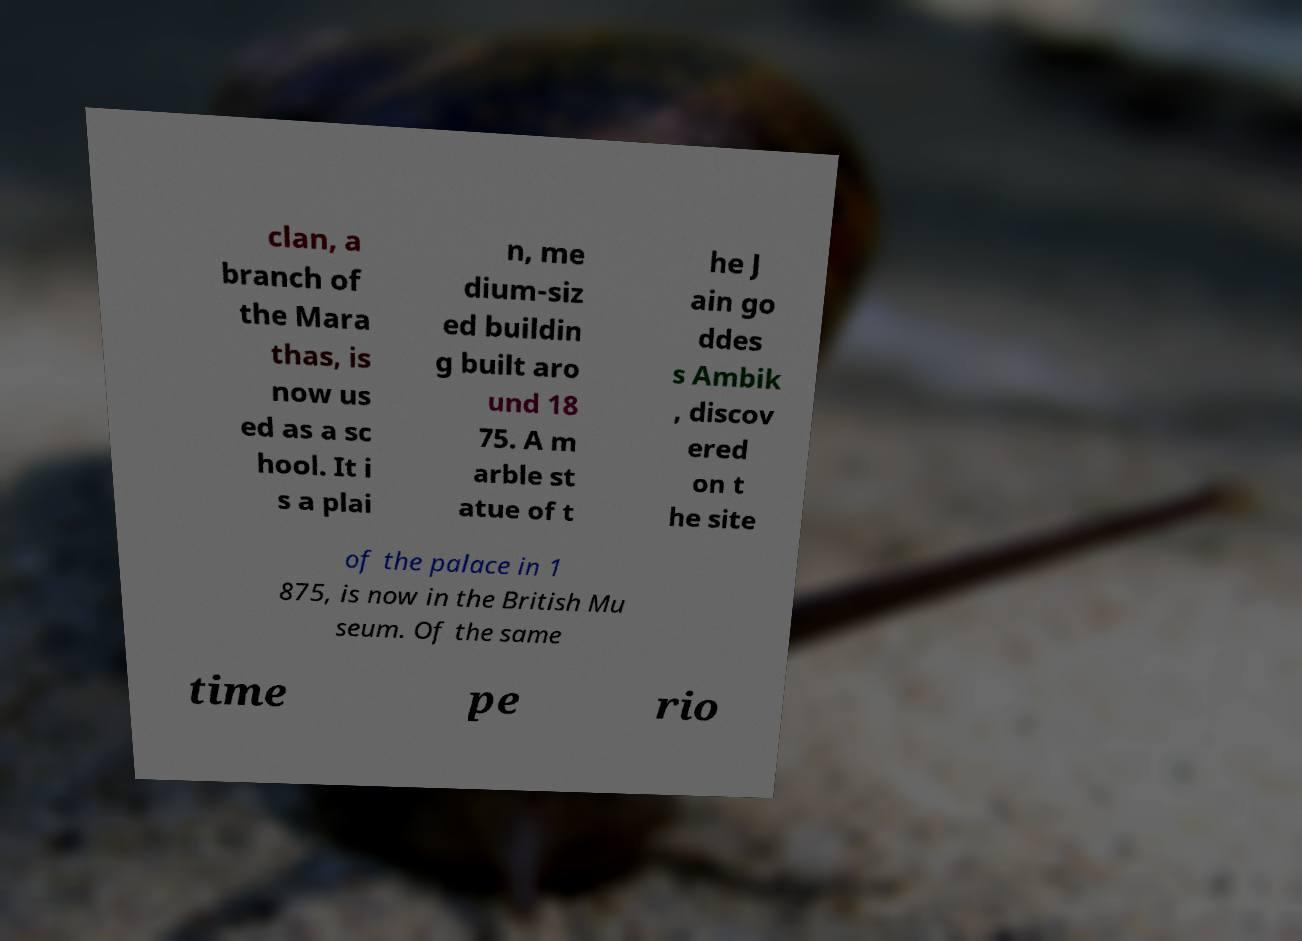What messages or text are displayed in this image? I need them in a readable, typed format. clan, a branch of the Mara thas, is now us ed as a sc hool. It i s a plai n, me dium-siz ed buildin g built aro und 18 75. A m arble st atue of t he J ain go ddes s Ambik , discov ered on t he site of the palace in 1 875, is now in the British Mu seum. Of the same time pe rio 